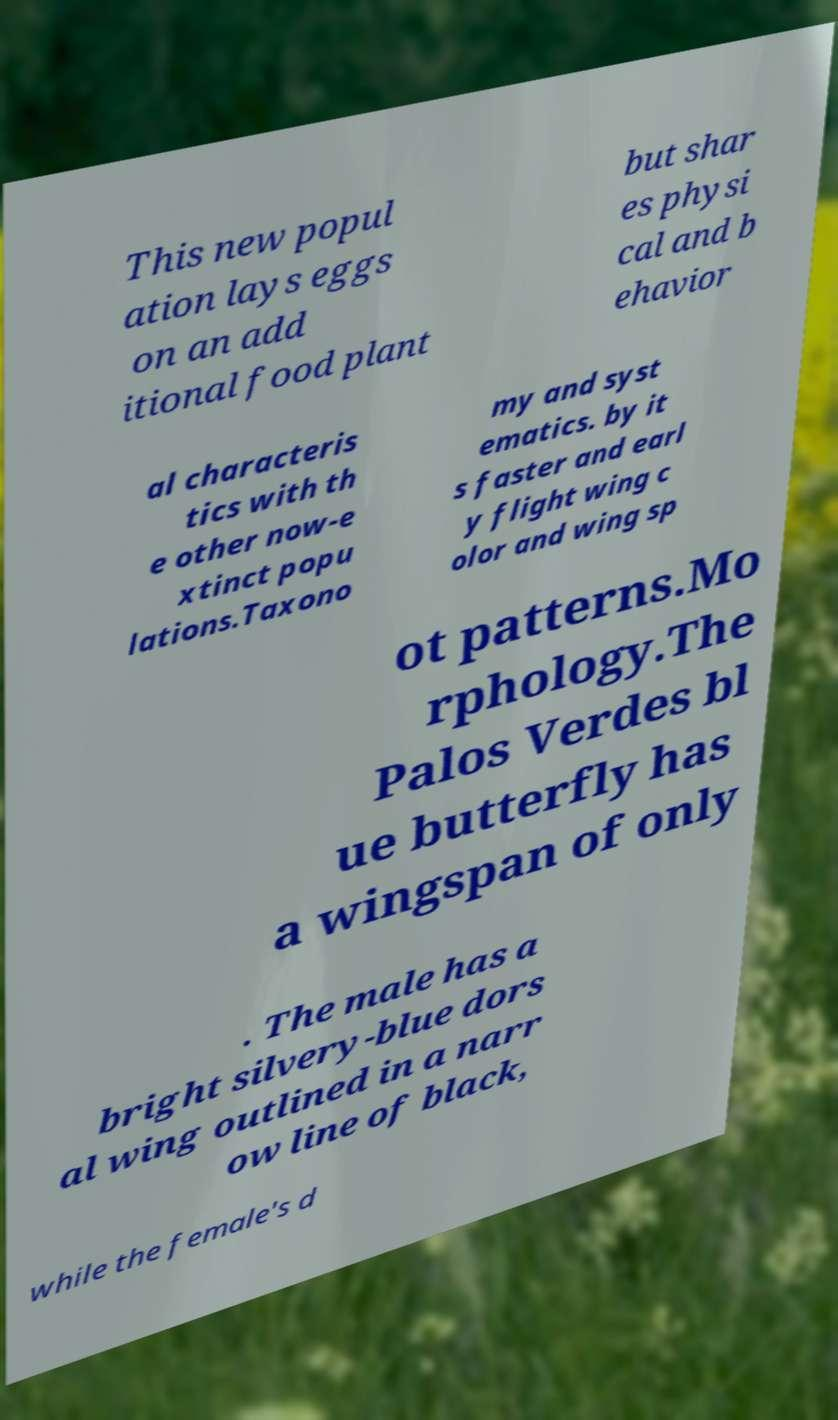I need the written content from this picture converted into text. Can you do that? This new popul ation lays eggs on an add itional food plant but shar es physi cal and b ehavior al characteris tics with th e other now-e xtinct popu lations.Taxono my and syst ematics. by it s faster and earl y flight wing c olor and wing sp ot patterns.Mo rphology.The Palos Verdes bl ue butterfly has a wingspan of only . The male has a bright silvery-blue dors al wing outlined in a narr ow line of black, while the female's d 